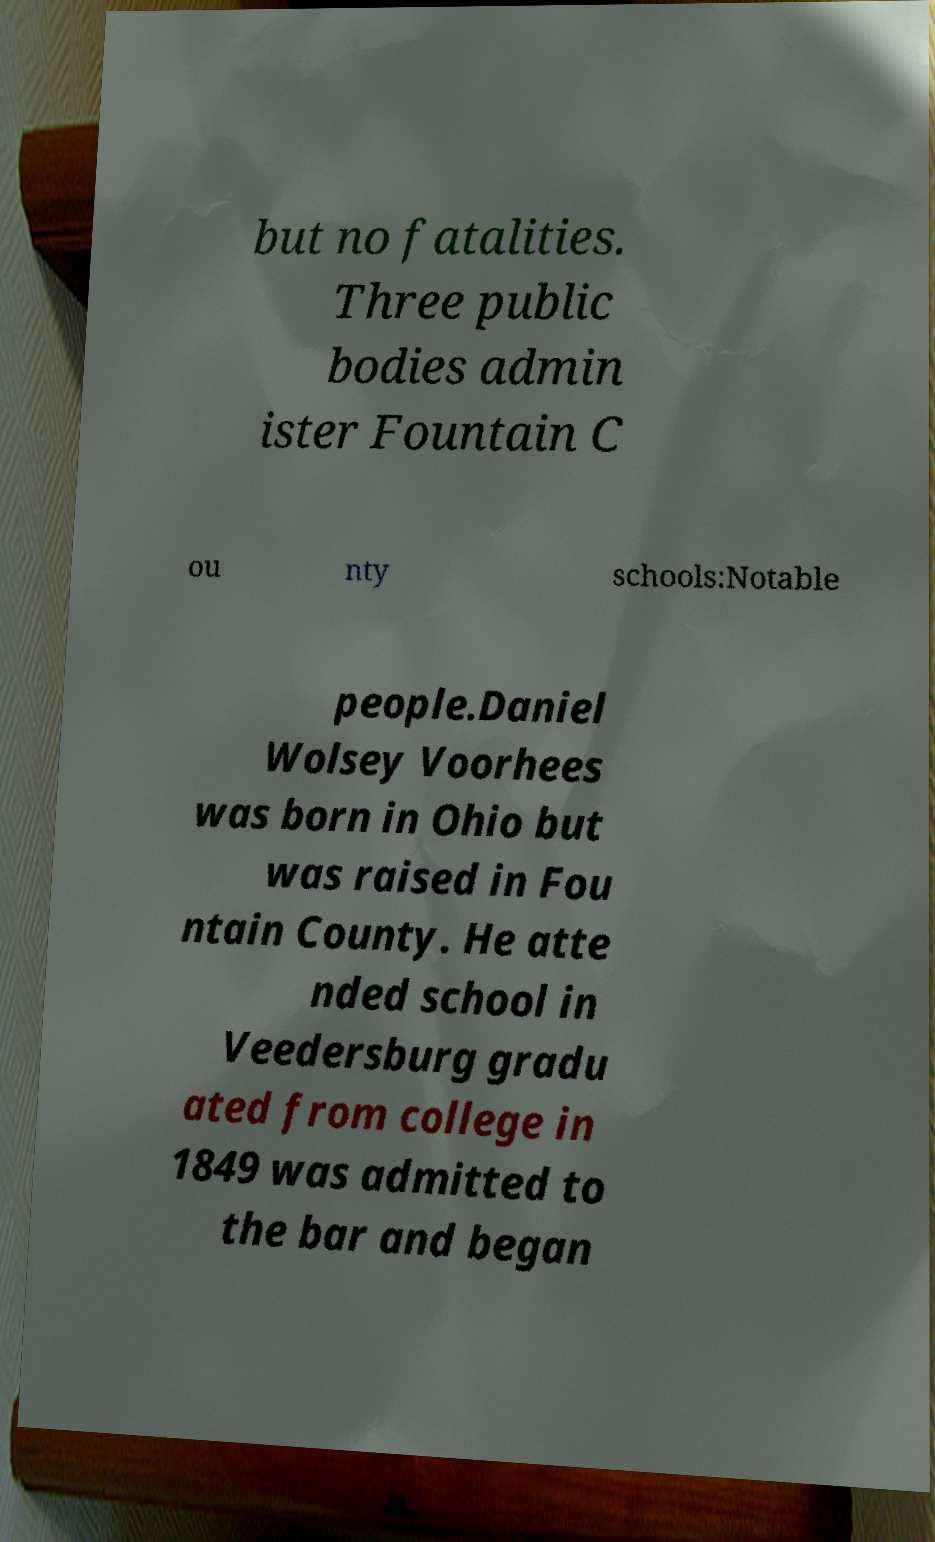Could you extract and type out the text from this image? but no fatalities. Three public bodies admin ister Fountain C ou nty schools:Notable people.Daniel Wolsey Voorhees was born in Ohio but was raised in Fou ntain County. He atte nded school in Veedersburg gradu ated from college in 1849 was admitted to the bar and began 